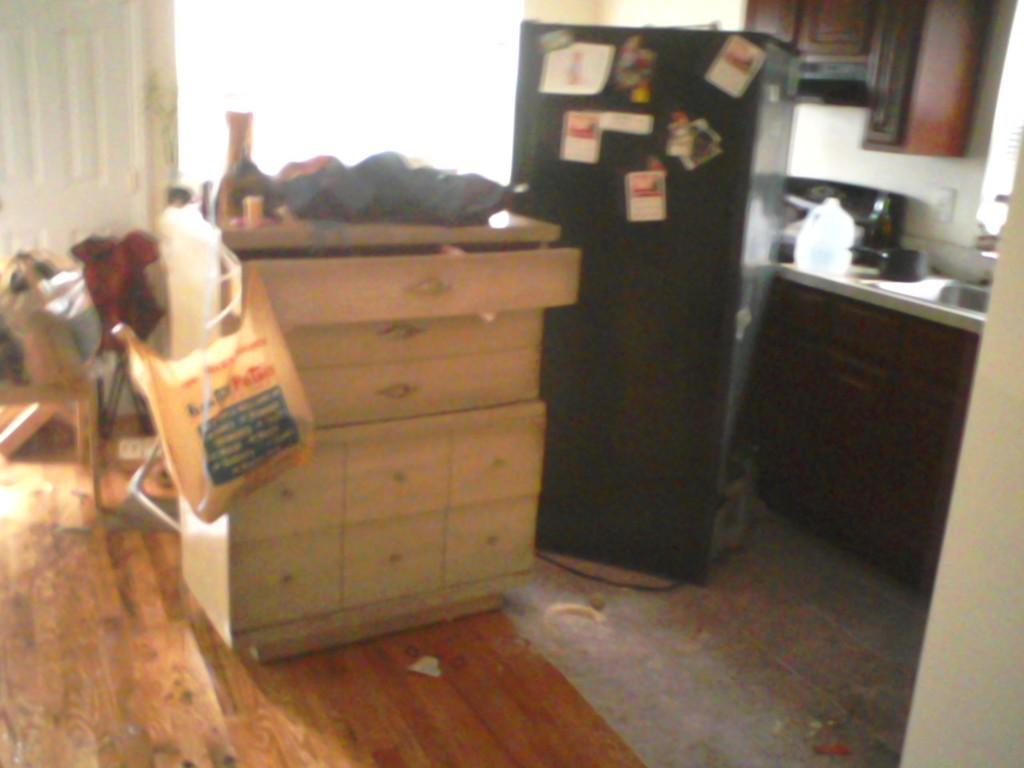Could you give a brief overview of what you see in this image? In the middle of the image, there is a cupboard on which, there are some objects. Beside this cupboard, there are some posters pasted on an object. On the right side, there is a sink and other objects on a table. In the background, there is a white color surface. 